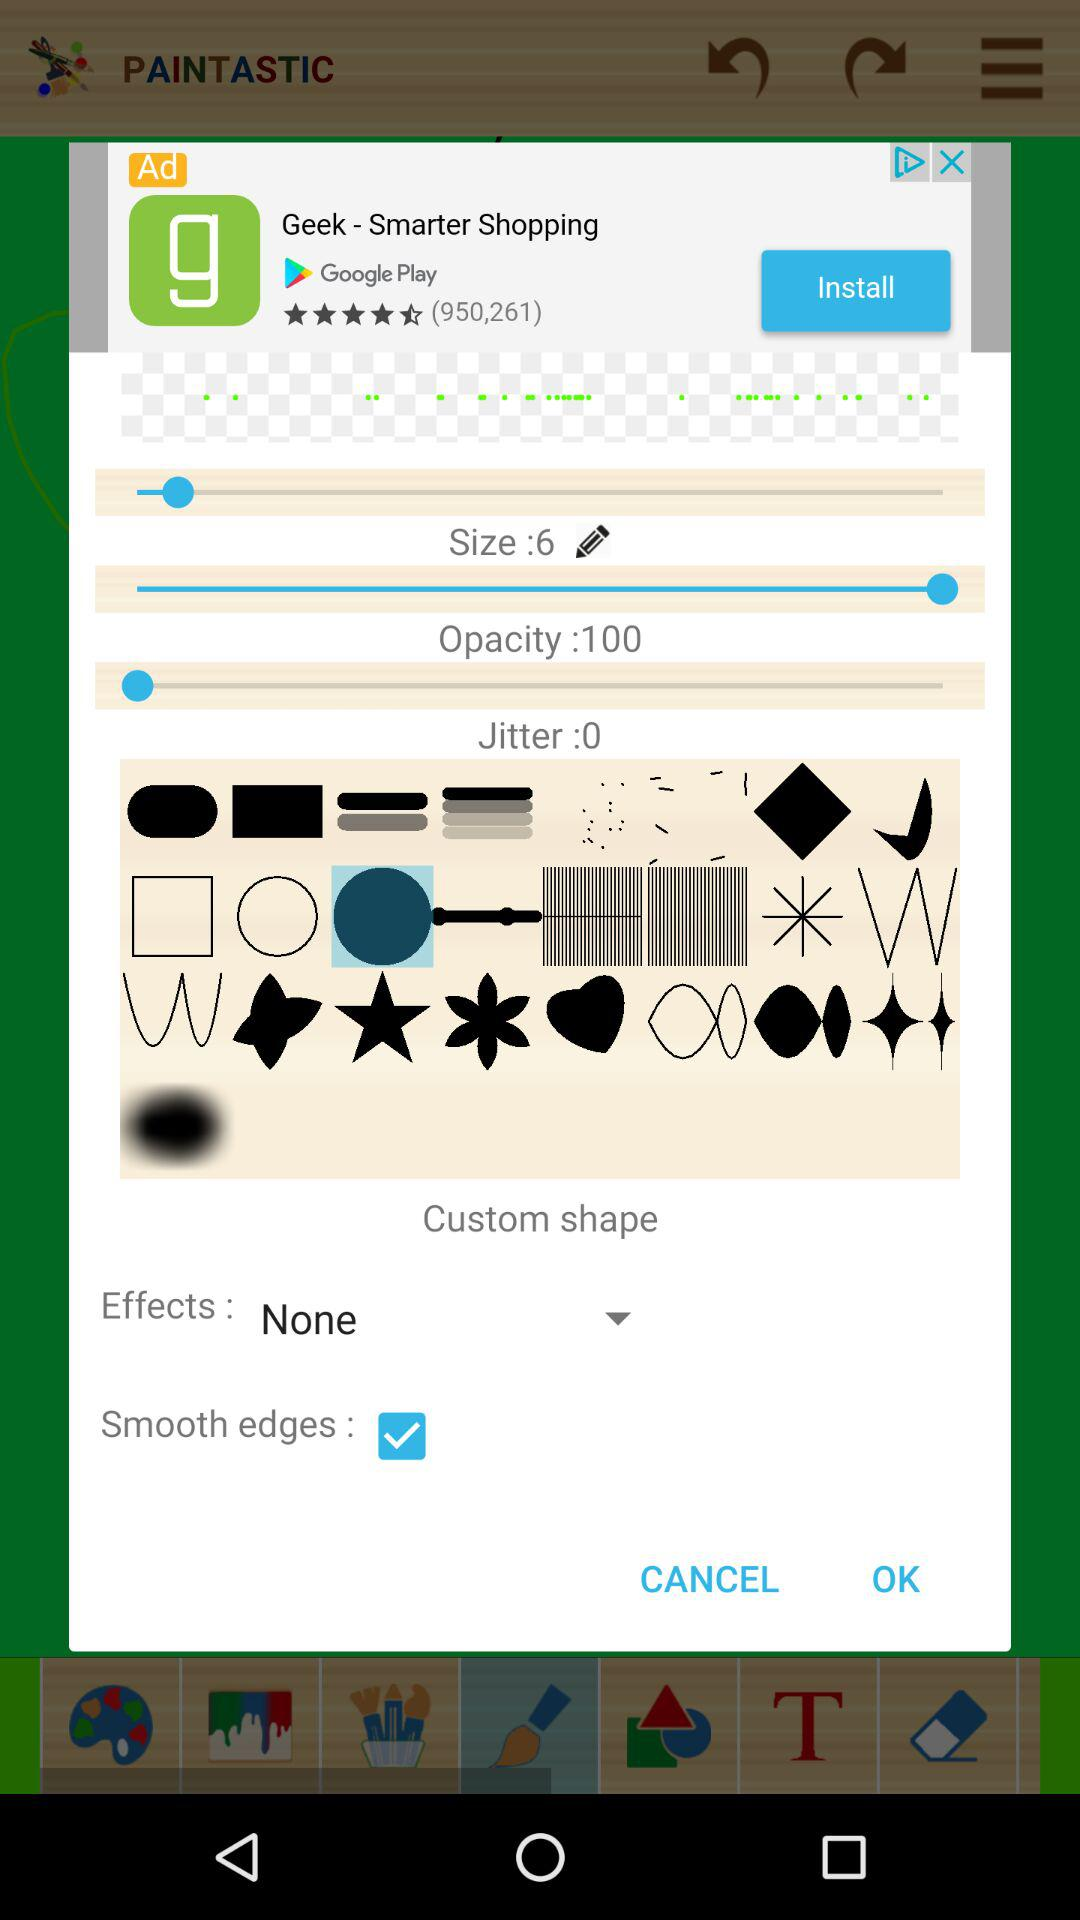What is the name of the application? The application name is Paintastic. 